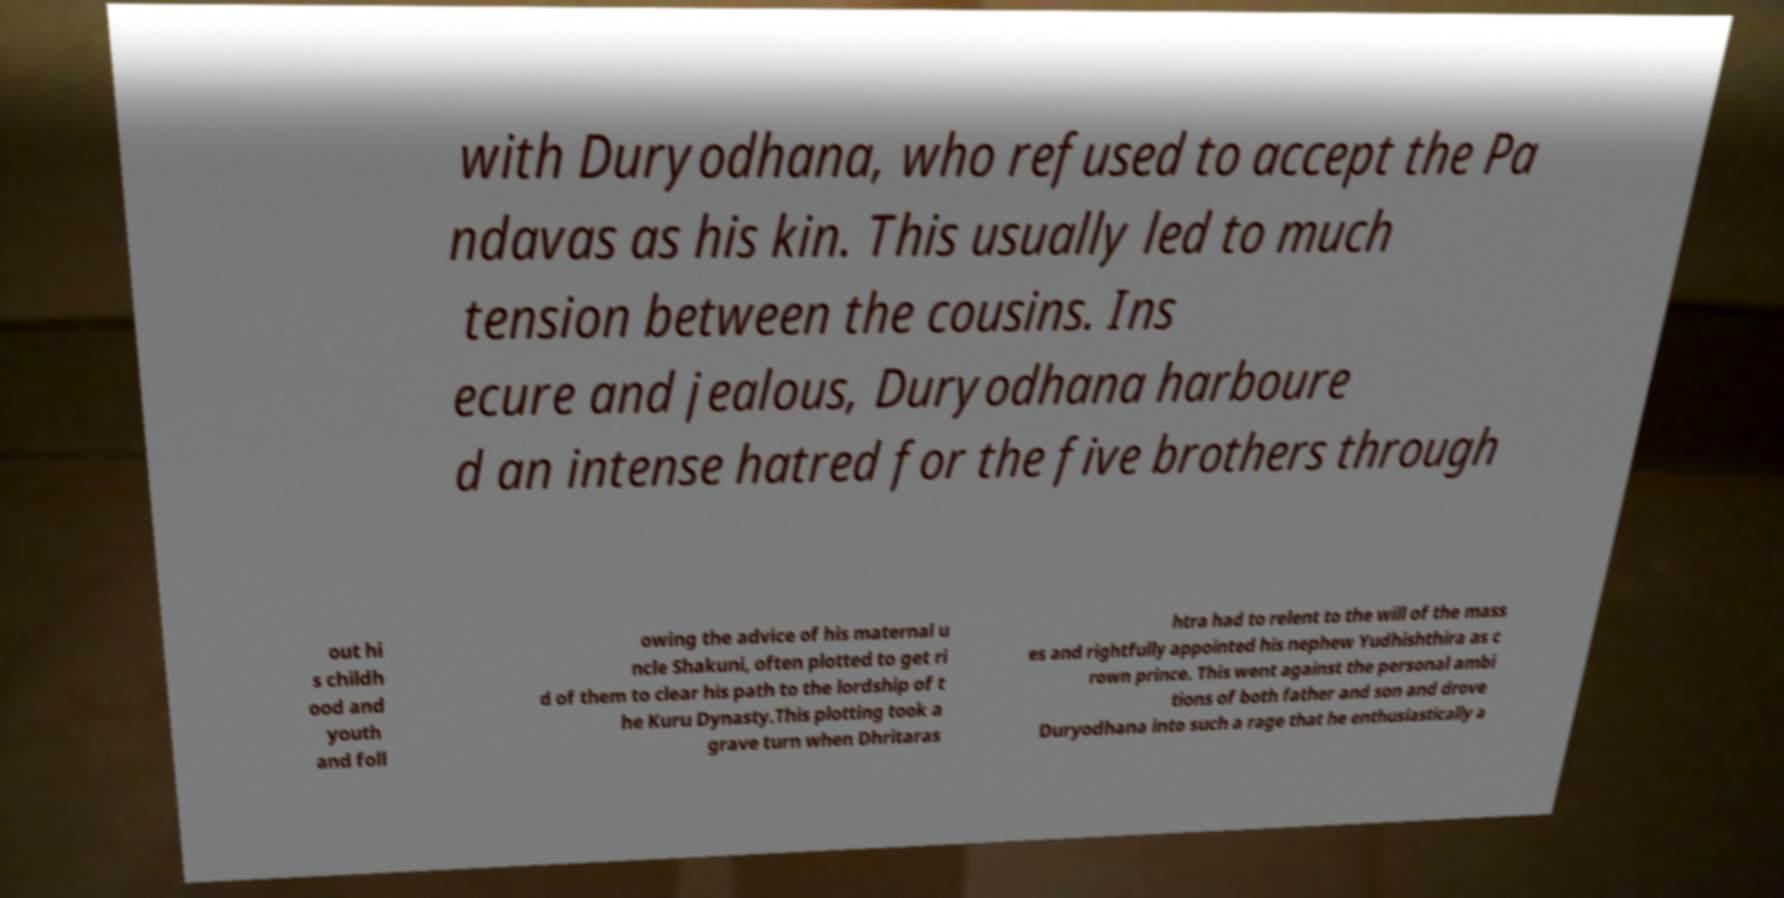Can you read and provide the text displayed in the image?This photo seems to have some interesting text. Can you extract and type it out for me? with Duryodhana, who refused to accept the Pa ndavas as his kin. This usually led to much tension between the cousins. Ins ecure and jealous, Duryodhana harboure d an intense hatred for the five brothers through out hi s childh ood and youth and foll owing the advice of his maternal u ncle Shakuni, often plotted to get ri d of them to clear his path to the lordship of t he Kuru Dynasty.This plotting took a grave turn when Dhritaras htra had to relent to the will of the mass es and rightfully appointed his nephew Yudhishthira as c rown prince. This went against the personal ambi tions of both father and son and drove Duryodhana into such a rage that he enthusiastically a 